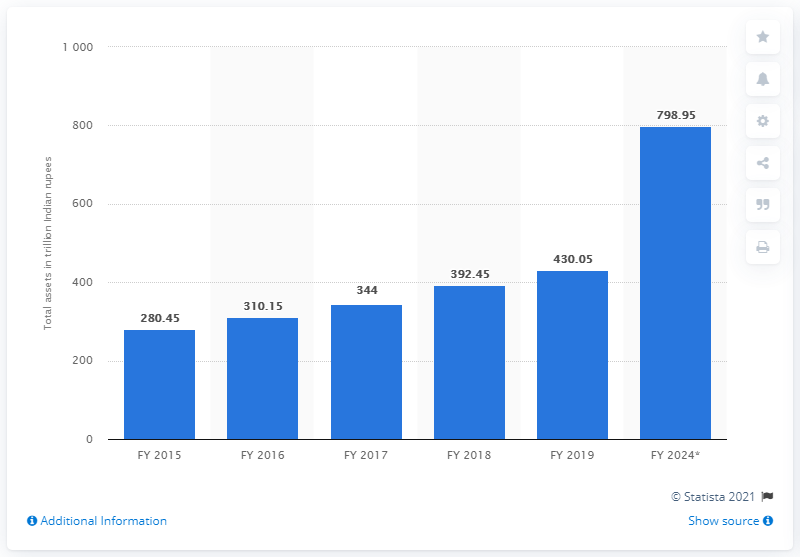Identify some key points in this picture. The estimated value of Indian wealth assets was projected to be 798.95 by 2024. In the 2019 financial year, the total amount of individual wealth assets held by Indians was 430.05. 